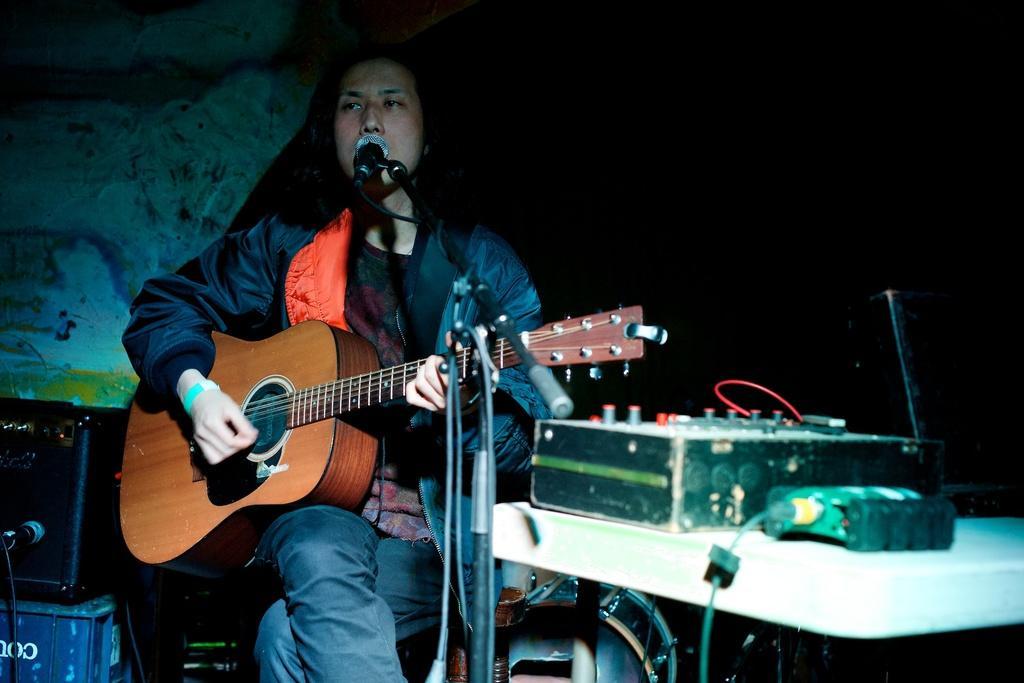Can you describe this image briefly? As we can see in the image there is a man sitting and holding guitar. In front of him there is a mic. 